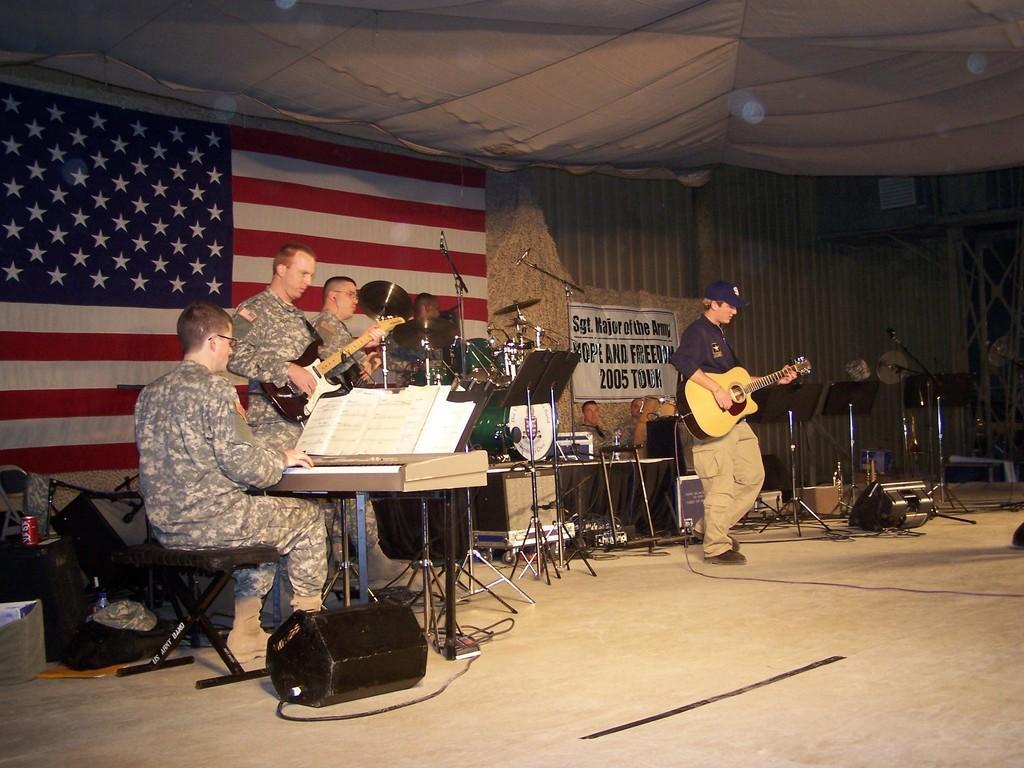In one or two sentences, can you explain what this image depicts? In the image we can see there are, military people are using musical instruments this is a microphone. Back of them there is a flag of america country. 